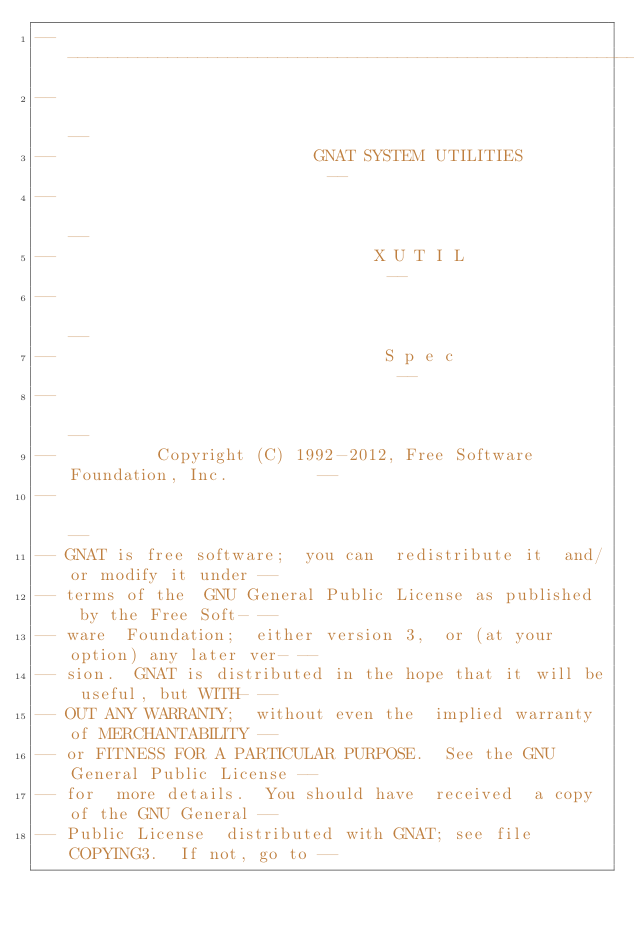Convert code to text. <code><loc_0><loc_0><loc_500><loc_500><_Ada_>------------------------------------------------------------------------------
--                                                                          --
--                          GNAT SYSTEM UTILITIES                           --
--                                                                          --
--                                X U T I L                                 --
--                                                                          --
--                                 S p e c                                  --
--                                                                          --
--          Copyright (C) 1992-2012, Free Software Foundation, Inc.         --
--                                                                          --
-- GNAT is free software;  you can  redistribute it  and/or modify it under --
-- terms of the  GNU General Public License as published  by the Free Soft- --
-- ware  Foundation;  either version 3,  or (at your option) any later ver- --
-- sion.  GNAT is distributed in the hope that it will be useful, but WITH- --
-- OUT ANY WARRANTY;  without even the  implied warranty of MERCHANTABILITY --
-- or FITNESS FOR A PARTICULAR PURPOSE.  See the GNU General Public License --
-- for  more details.  You should have  received  a copy of the GNU General --
-- Public License  distributed with GNAT; see file COPYING3.  If not, go to --</code> 